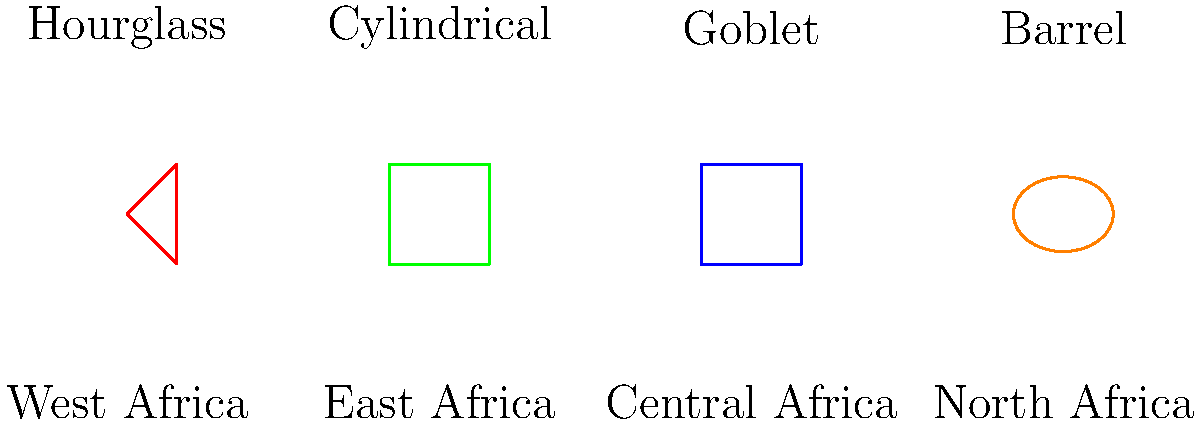Match the African regions to their characteristic drum shapes based on the image. Which region is associated with the goblet-shaped drum? To answer this question, we need to analyze the image and identify the goblet-shaped drum and its corresponding region. Let's break it down step-by-step:

1. Observe the four drum shapes presented in the image:
   - Hourglass shape (red)
   - Cylindrical shape (green)
   - Goblet shape (blue)
   - Barrel shape (orange)

2. Identify the goblet-shaped drum:
   The goblet-shaped drum is the third from the left, colored blue.

3. Match the goblet shape to its corresponding region:
   Directly below the goblet-shaped drum, we can see the region label "Central Africa".

Therefore, the region associated with the goblet-shaped drum is Central Africa.
Answer: Central Africa 